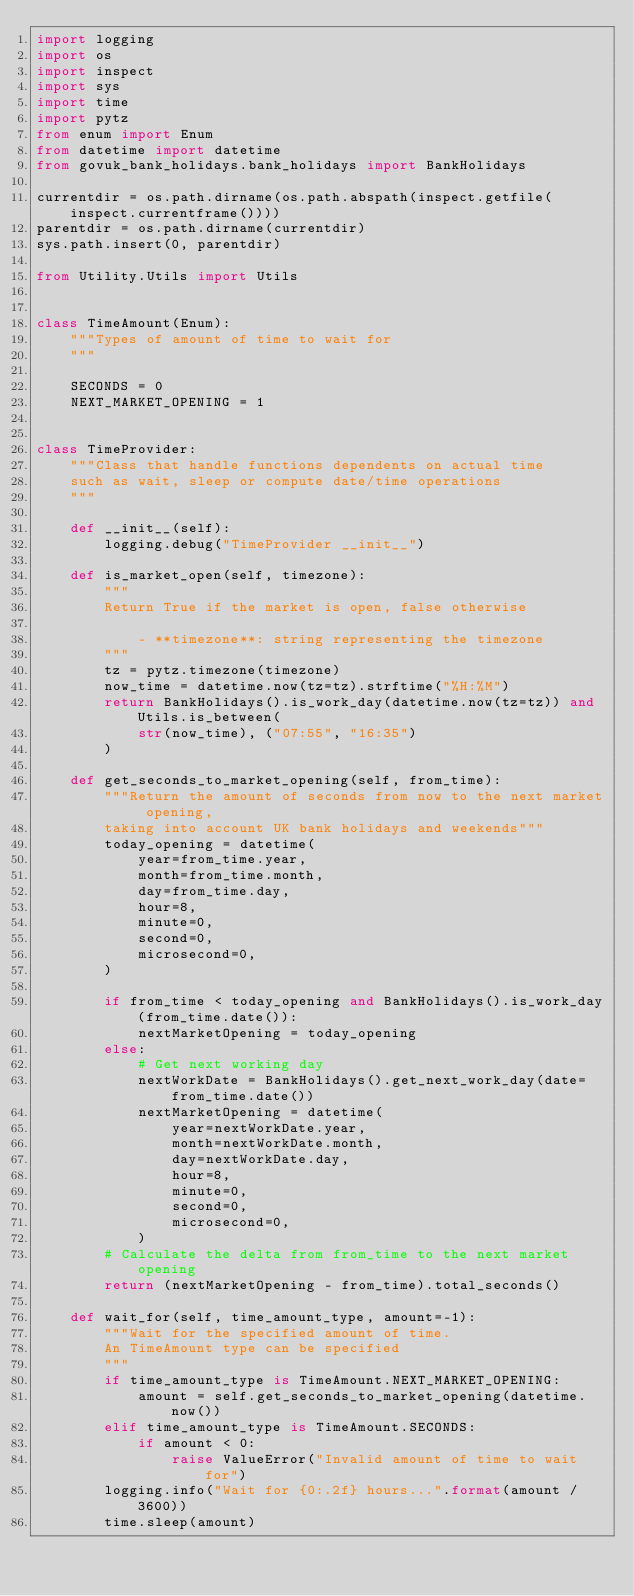Convert code to text. <code><loc_0><loc_0><loc_500><loc_500><_Python_>import logging
import os
import inspect
import sys
import time
import pytz
from enum import Enum
from datetime import datetime
from govuk_bank_holidays.bank_holidays import BankHolidays

currentdir = os.path.dirname(os.path.abspath(inspect.getfile(inspect.currentframe())))
parentdir = os.path.dirname(currentdir)
sys.path.insert(0, parentdir)

from Utility.Utils import Utils


class TimeAmount(Enum):
    """Types of amount of time to wait for
    """

    SECONDS = 0
    NEXT_MARKET_OPENING = 1


class TimeProvider:
    """Class that handle functions dependents on actual time
    such as wait, sleep or compute date/time operations
    """

    def __init__(self):
        logging.debug("TimeProvider __init__")

    def is_market_open(self, timezone):
        """
        Return True if the market is open, false otherwise

            - **timezone**: string representing the timezone
        """
        tz = pytz.timezone(timezone)
        now_time = datetime.now(tz=tz).strftime("%H:%M")
        return BankHolidays().is_work_day(datetime.now(tz=tz)) and Utils.is_between(
            str(now_time), ("07:55", "16:35")
        )

    def get_seconds_to_market_opening(self, from_time):
        """Return the amount of seconds from now to the next market opening,
        taking into account UK bank holidays and weekends"""
        today_opening = datetime(
            year=from_time.year,
            month=from_time.month,
            day=from_time.day,
            hour=8,
            minute=0,
            second=0,
            microsecond=0,
        )

        if from_time < today_opening and BankHolidays().is_work_day(from_time.date()):
            nextMarketOpening = today_opening
        else:
            # Get next working day
            nextWorkDate = BankHolidays().get_next_work_day(date=from_time.date())
            nextMarketOpening = datetime(
                year=nextWorkDate.year,
                month=nextWorkDate.month,
                day=nextWorkDate.day,
                hour=8,
                minute=0,
                second=0,
                microsecond=0,
            )
        # Calculate the delta from from_time to the next market opening
        return (nextMarketOpening - from_time).total_seconds()

    def wait_for(self, time_amount_type, amount=-1):
        """Wait for the specified amount of time.
        An TimeAmount type can be specified
        """
        if time_amount_type is TimeAmount.NEXT_MARKET_OPENING:
            amount = self.get_seconds_to_market_opening(datetime.now())
        elif time_amount_type is TimeAmount.SECONDS:
            if amount < 0:
                raise ValueError("Invalid amount of time to wait for")
        logging.info("Wait for {0:.2f} hours...".format(amount / 3600))
        time.sleep(amount)

</code> 